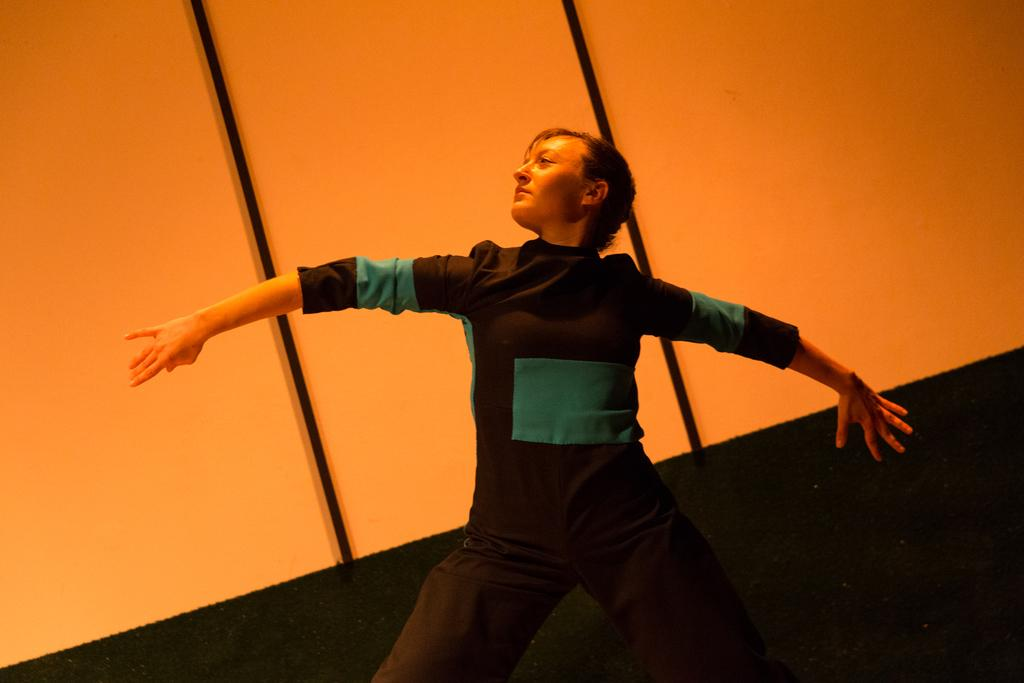Who is the main subject in the image? There is a person in the center of the image. What is the person wearing? The person is wearing a t-shirt. What is the person doing in the image? The person appears to be dancing. What can be seen in the background of the image? There is a wall visible in the background of the image, along with other items. How many dust particles can be seen floating around the person in the image? There is no mention of dust particles in the image, so it is not possible to determine their number. 